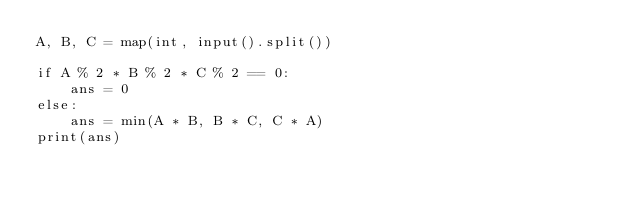Convert code to text. <code><loc_0><loc_0><loc_500><loc_500><_Python_>A, B, C = map(int, input().split())

if A % 2 * B % 2 * C % 2 == 0:
    ans = 0
else:
    ans = min(A * B, B * C, C * A)
print(ans)
</code> 